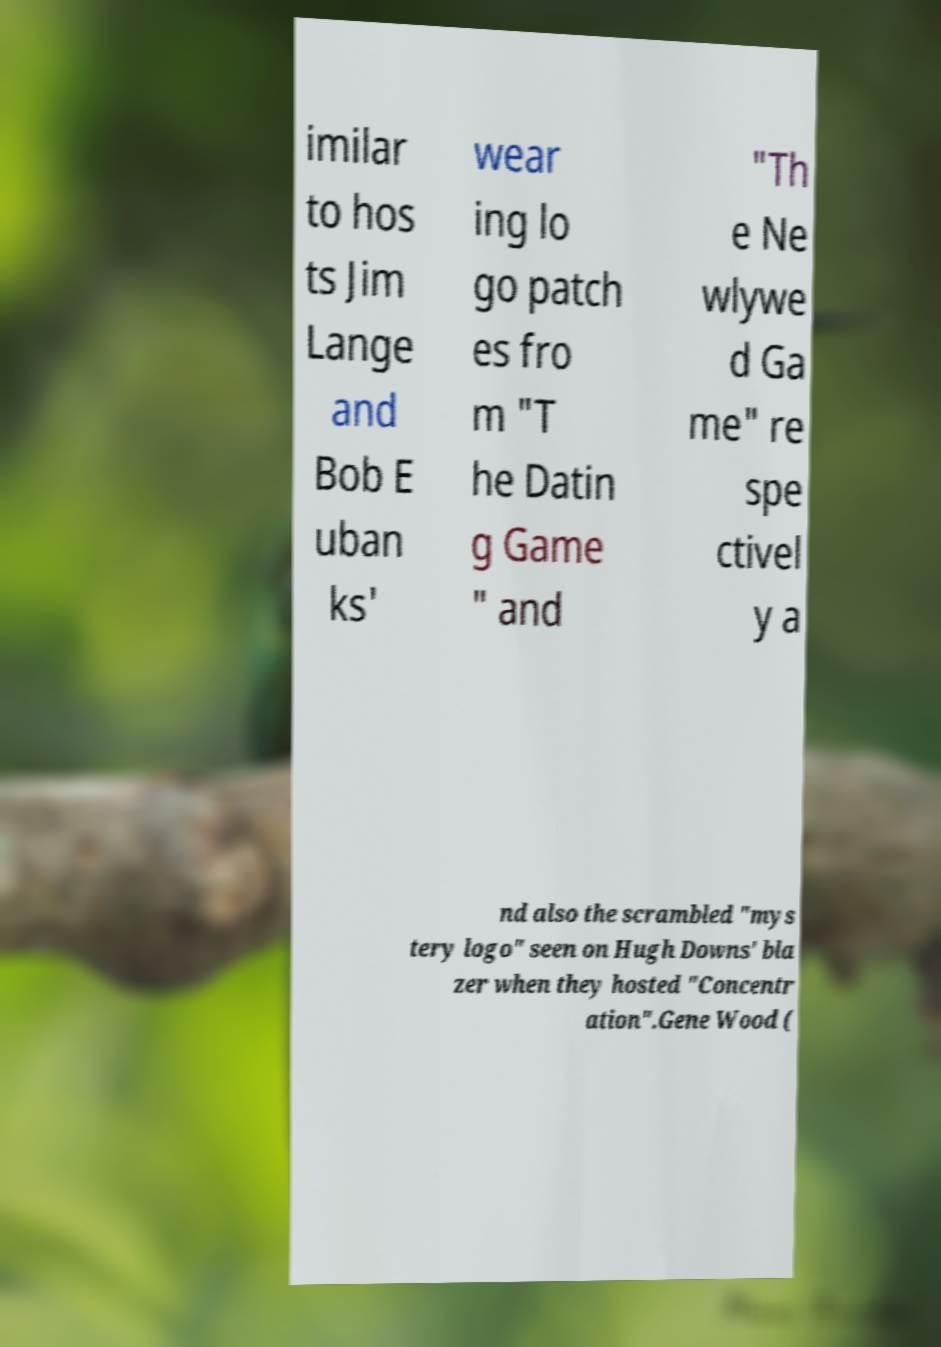There's text embedded in this image that I need extracted. Can you transcribe it verbatim? imilar to hos ts Jim Lange and Bob E uban ks' wear ing lo go patch es fro m "T he Datin g Game " and "Th e Ne wlywe d Ga me" re spe ctivel y a nd also the scrambled "mys tery logo" seen on Hugh Downs' bla zer when they hosted "Concentr ation".Gene Wood ( 